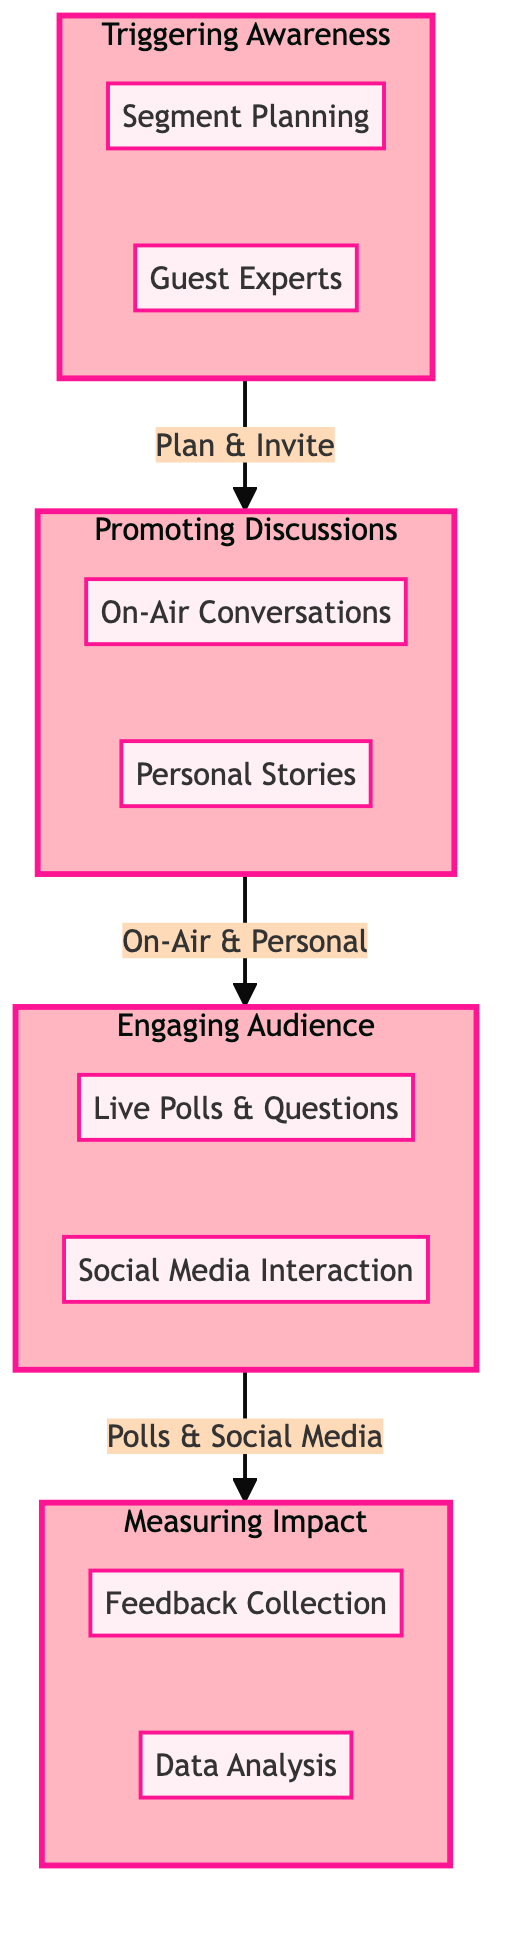What is the first step in Triggering Awareness? The first step in the Triggering Awareness section is Segment Planning, where producers and co-hosts plan segments focusing on mental health topics
Answer: Segment Planning How many steps are there in Promoting Discussions? The Promoting Discussions section has two steps: On-Air Conversations and Personal Stories, making a total of two steps
Answer: 2 Which co-host leads discussions in the On-Air Conversations? The diagram indicates that Whoopi Goldberg and Joy Behar lead discussions in the On-Air Conversations step, highlighting their roles in promoting mental health discussions
Answer: Whoopi Goldberg and Joy Behar What connects Engaging Audience to Measuring Impact? Engaging Audience is connected to Measuring Impact by the action Polls & Social Media, indicating how viewer engagement leads into assessing impact
Answer: Polls & Social Media What action is taken after collecting feedback? After Feedback Collection, the next step is Data Analysis, showing that feedback directly leads to analysis of viewer engagement and awareness
Answer: Data Analysis In which section do Live Polls & Questions appear? Live Polls & Questions is found in the Engaging Audience section and represents a method to interact with the audience regarding mental health topics
Answer: Engaging Audience How do co-hosts promote mental health awareness through personal experiences? Co-hosts promote mental health awareness by sharing their own experiences or stories related to mental health, which occurs in the Personal Stories step
Answer: Personal Stories What is the last step in the entire clinical pathway? The last step in the clinical pathway is Data Analysis, which follows the Feedback Collection step and serves to evaluate the overall impact
Answer: Data Analysis 